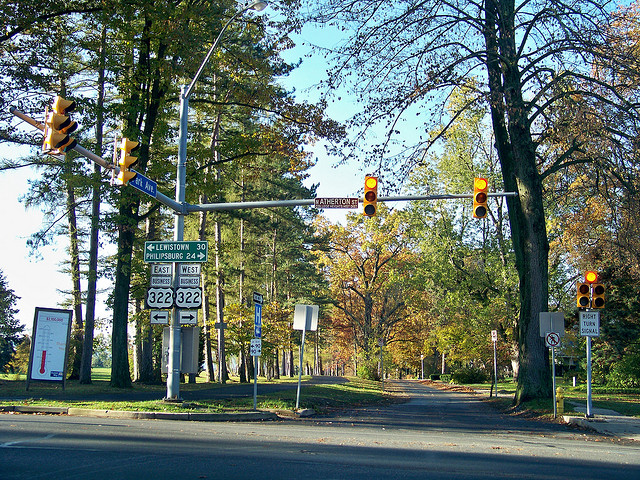Please transcribe the text in this image. LEMISTOWNT PHILIPSBURG 24 30 WEST 322 322 EAST ATHERTON 